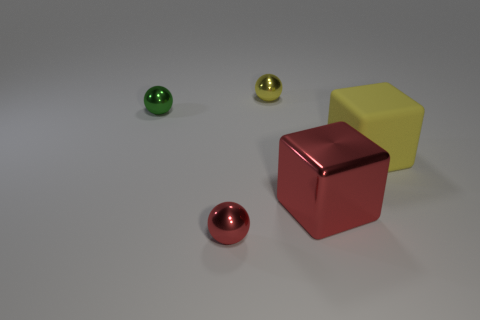What materials do the objects in the scene seem to be made of? The objects in the image appear to have different materials. The sphere in the front looks metallic, possibly with a glossy finish. The red cube appears to have a reflective, metallic surface as well, while the yellow block might be made of a matte plastic or painted wood. 